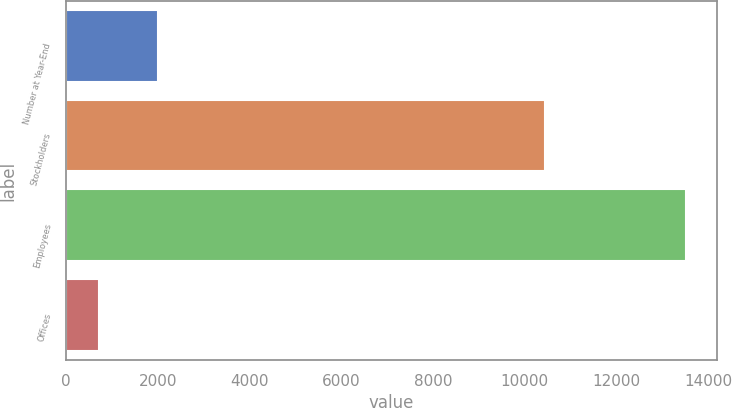Convert chart. <chart><loc_0><loc_0><loc_500><loc_500><bar_chart><fcel>Number at Year-End<fcel>Stockholders<fcel>Employees<fcel>Offices<nl><fcel>2005<fcel>10437<fcel>13525<fcel>724<nl></chart> 